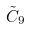<formula> <loc_0><loc_0><loc_500><loc_500>\tilde { C } _ { 9 }</formula> 